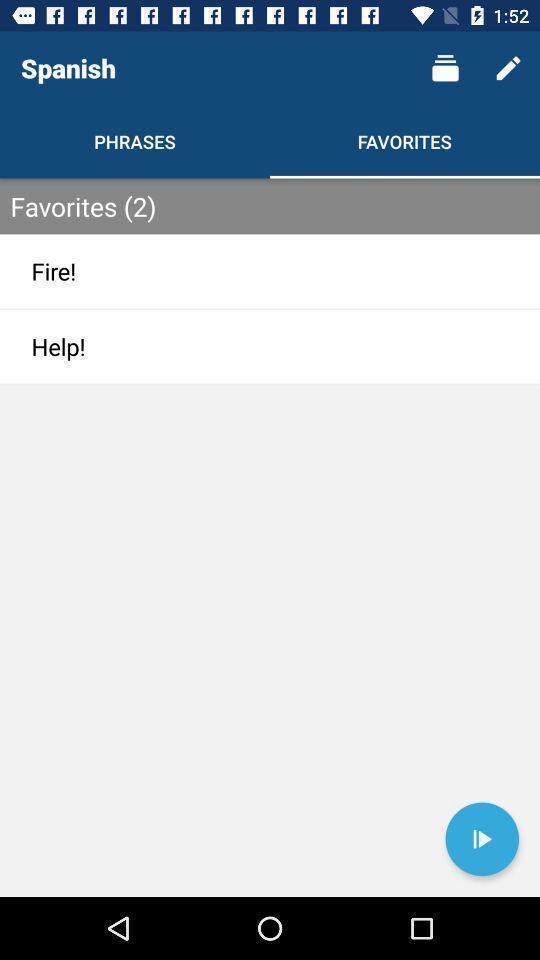What details can you identify in this image? Page showing categories in favorites. 